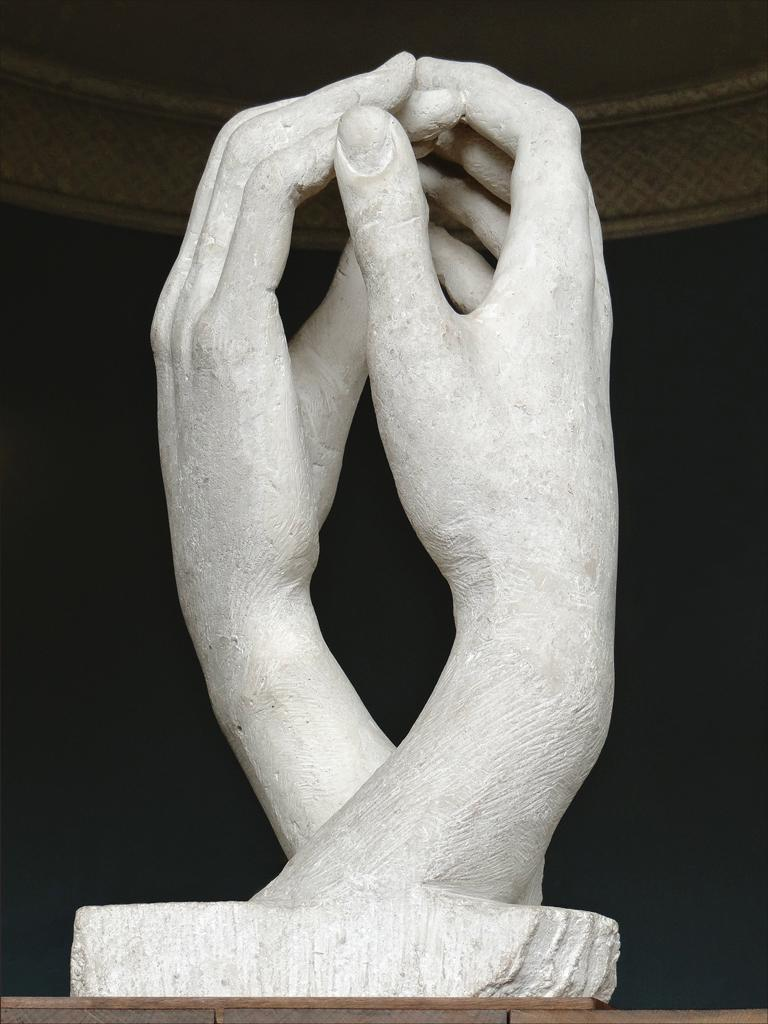What is the main subject of the image? The main subject of the image is a statue. What does the statue represent? The statue represents two hands. What can be observed about the background of the image? The background of the image is dark. What type of jar can be seen in the hands of the statue? There is no jar present in the image; the statue represents two hands. Can you hear the statue making any sounds in the image? The image is static, and there are no sounds associated with the statue or the image. 